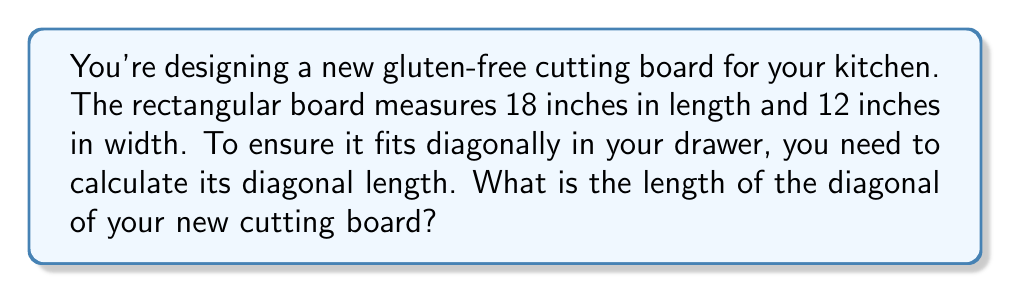What is the answer to this math problem? Let's approach this step-by-step using the Pythagorean theorem:

1) In a rectangle, the diagonal forms the hypotenuse of a right triangle, with the length and width as the other two sides.

2) Let's define our variables:
   $l$ = length = 18 inches
   $w$ = width = 12 inches
   $d$ = diagonal (what we're solving for)

3) The Pythagorean theorem states: $a^2 + b^2 = c^2$, where $c$ is the hypotenuse.

4) Applying this to our cutting board:

   $$l^2 + w^2 = d^2$$

5) Substituting our known values:

   $$18^2 + 12^2 = d^2$$

6) Simplify:

   $$324 + 144 = d^2$$
   $$468 = d^2$$

7) To find $d$, we take the square root of both sides:

   $$\sqrt{468} = d$$

8) Simplify the square root:

   $$\sqrt{4 * 117} = d$$
   $$2\sqrt{117} \approx 21.63 \text{ inches}$$

[asy]
unitsize(0.2 inch);
draw((0,0)--(18,0)--(18,12)--(0,12)--cycle);
draw((0,0)--(18,12),dashed);
label("18\"", (9,-0.5));
label("12\"", (18.5,6));
label("d", (8,7));
[/asy]
Answer: $21.63$ inches 